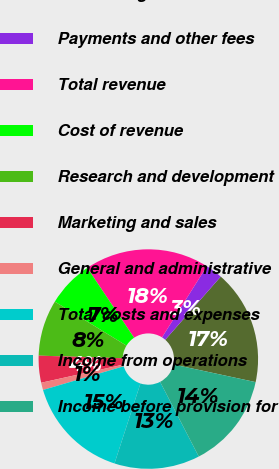Convert chart. <chart><loc_0><loc_0><loc_500><loc_500><pie_chart><fcel>Advertising<fcel>Payments and other fees<fcel>Total revenue<fcel>Cost of revenue<fcel>Research and development<fcel>Marketing and sales<fcel>General and administrative<fcel>Total costs and expenses<fcel>Income from operations<fcel>Income before provision for<nl><fcel>16.9%<fcel>2.52%<fcel>18.34%<fcel>6.84%<fcel>8.27%<fcel>3.96%<fcel>1.08%<fcel>15.47%<fcel>12.59%<fcel>14.03%<nl></chart> 